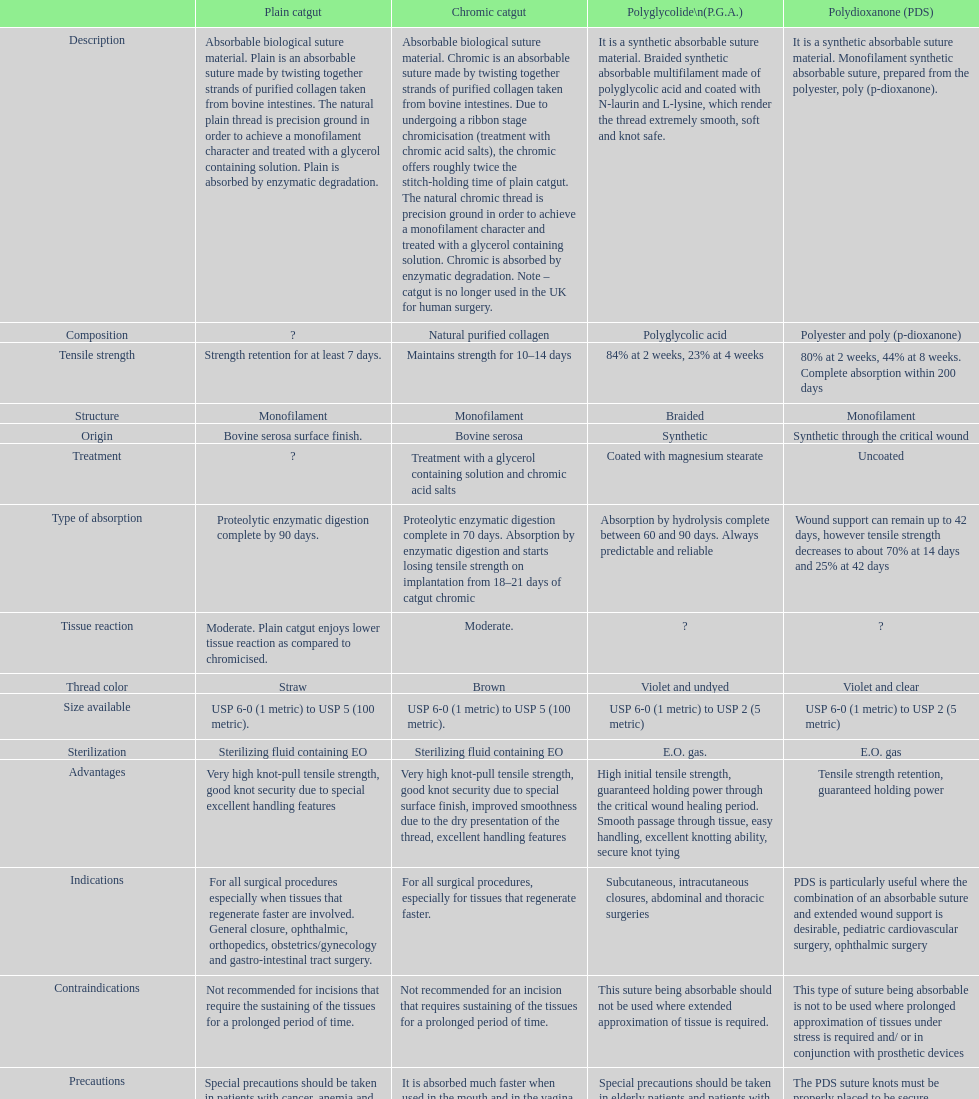What type of sutures are no longer used in the u.k. for human surgery? Chromic catgut. 